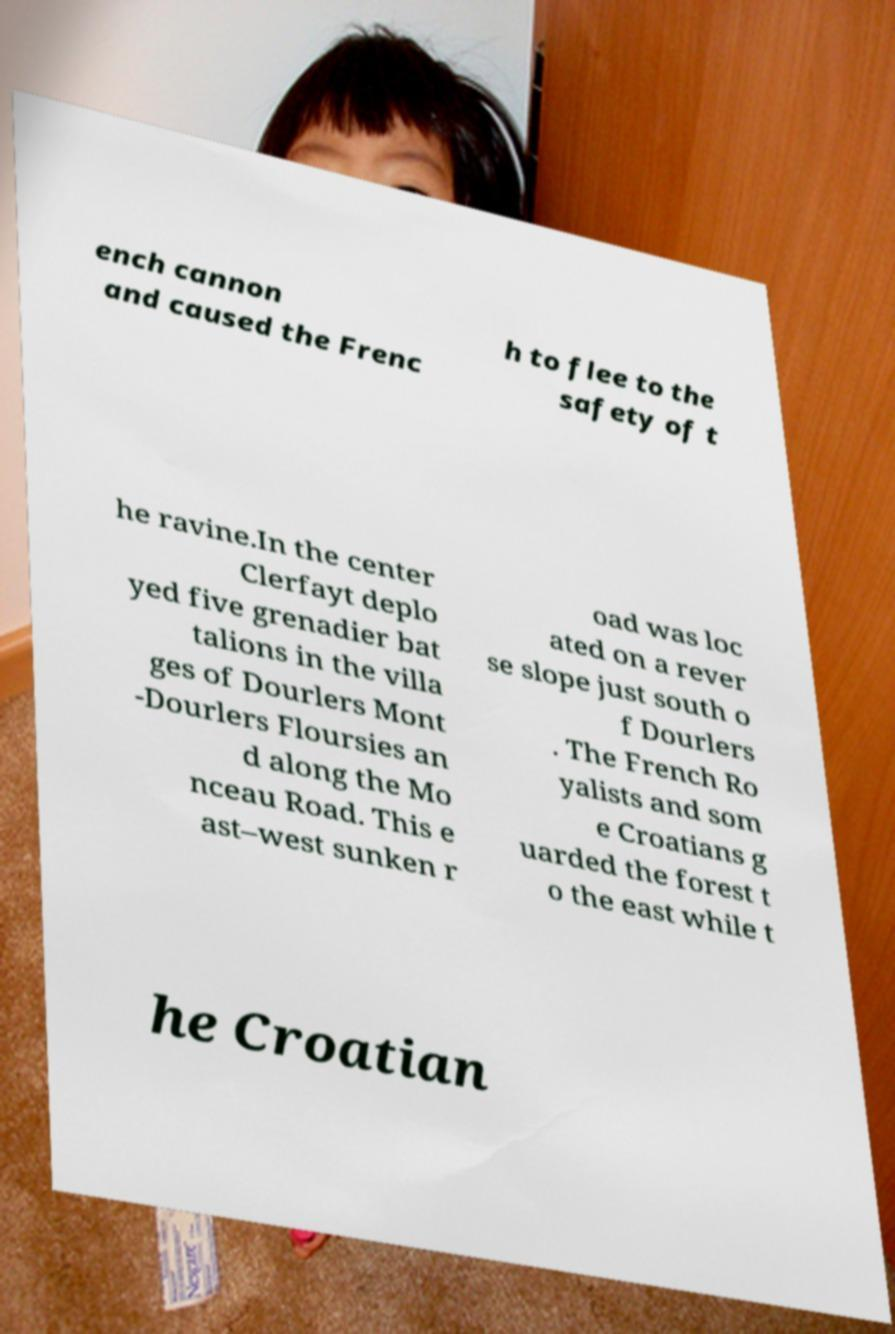Could you extract and type out the text from this image? ench cannon and caused the Frenc h to flee to the safety of t he ravine.In the center Clerfayt deplo yed five grenadier bat talions in the villa ges of Dourlers Mont -Dourlers Floursies an d along the Mo nceau Road. This e ast–west sunken r oad was loc ated on a rever se slope just south o f Dourlers . The French Ro yalists and som e Croatians g uarded the forest t o the east while t he Croatian 